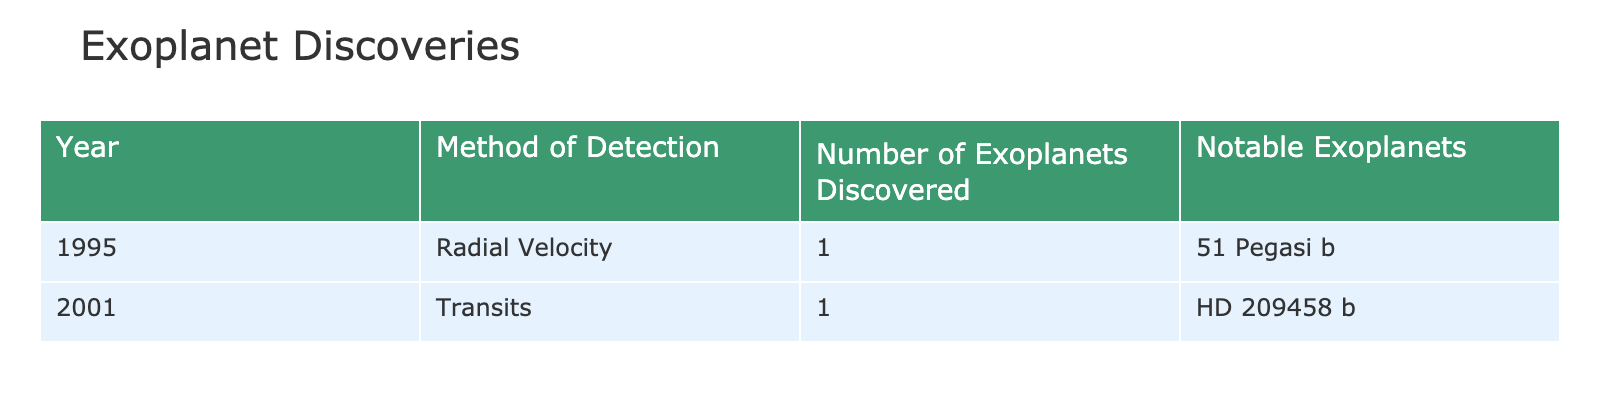What year was the first exoplanet discovered? The table indicates that the first exoplanet, 51 Pegasi b, was discovered in 1995.
Answer: 1995 How many exoplanets were discovered in 2001? According to the table, there was 1 exoplanet discovered in 2001.
Answer: 1 What method of detection was used for the discovery of HD 209458 b? The table shows that HD 209458 b was discovered using the Transits method in 2001.
Answer: Transits Is it true that 51 Pegasi b was discovered by the Radial Velocity method? The table confirms that 51 Pegasi b was indeed discovered using the Radial Velocity method in 1995.
Answer: Yes What is the total number of exoplanets discovered by 2001? To find the total, we add the exoplanets discovered in 1995 (1) and in 2001 (1), giving us a total of 2 exoplanets.
Answer: 2 Which exoplanet discovery method was first used? By examining the years listed, the Radial Velocity method used for 51 Pegasi b in 1995 occurred before the Transits method used for HD 209458 b in 2001, indicating Radial Velocity was the first.
Answer: Radial Velocity How many exoplanets were discovered via the Radial Velocity method? The table lists only 1 exoplanet, 51 Pegasi b, that was discovered using the Radial Velocity method in 1995.
Answer: 1 Are there any notable exoplanets discovered in 1995? Yes, the table lists 51 Pegasi b as a notable exoplanet discovered in 1995.
Answer: Yes Which year had more exoplanets discovered, 1995 or 2001? The table shows that both years had 1 exoplanet discovered. Thus, they are equal in number.
Answer: Neither, they are equal 